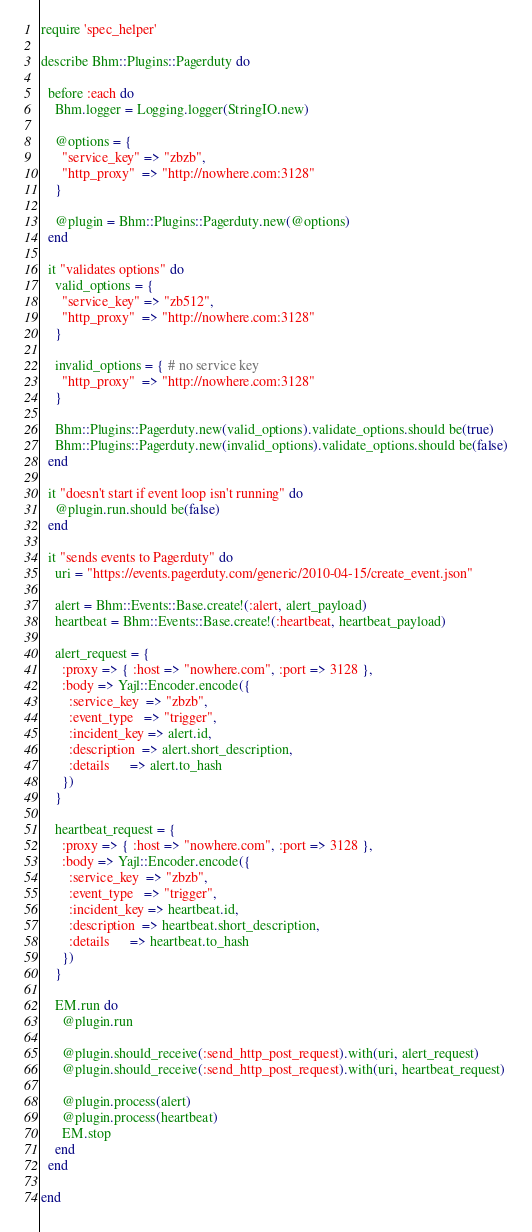<code> <loc_0><loc_0><loc_500><loc_500><_Ruby_>require 'spec_helper'

describe Bhm::Plugins::Pagerduty do

  before :each do
    Bhm.logger = Logging.logger(StringIO.new)

    @options = {
      "service_key" => "zbzb",
      "http_proxy"  => "http://nowhere.com:3128"
    }

    @plugin = Bhm::Plugins::Pagerduty.new(@options)
  end

  it "validates options" do
    valid_options = {
      "service_key" => "zb512",
      "http_proxy"  => "http://nowhere.com:3128"
    }

    invalid_options = { # no service key
      "http_proxy"  => "http://nowhere.com:3128"
    }

    Bhm::Plugins::Pagerduty.new(valid_options).validate_options.should be(true)
    Bhm::Plugins::Pagerduty.new(invalid_options).validate_options.should be(false)
  end

  it "doesn't start if event loop isn't running" do
    @plugin.run.should be(false)
  end

  it "sends events to Pagerduty" do
    uri = "https://events.pagerduty.com/generic/2010-04-15/create_event.json"

    alert = Bhm::Events::Base.create!(:alert, alert_payload)
    heartbeat = Bhm::Events::Base.create!(:heartbeat, heartbeat_payload)

    alert_request = {
      :proxy => { :host => "nowhere.com", :port => 3128 },
      :body => Yajl::Encoder.encode({
        :service_key  => "zbzb",
        :event_type   => "trigger",
        :incident_key => alert.id,
        :description  => alert.short_description,
        :details      => alert.to_hash
      })
    }

    heartbeat_request = {
      :proxy => { :host => "nowhere.com", :port => 3128 },
      :body => Yajl::Encoder.encode({
        :service_key  => "zbzb",
        :event_type   => "trigger",
        :incident_key => heartbeat.id,
        :description  => heartbeat.short_description,
        :details      => heartbeat.to_hash
      })
    }

    EM.run do
      @plugin.run

      @plugin.should_receive(:send_http_post_request).with(uri, alert_request)
      @plugin.should_receive(:send_http_post_request).with(uri, heartbeat_request)

      @plugin.process(alert)
      @plugin.process(heartbeat)
      EM.stop
    end
  end

end
</code> 